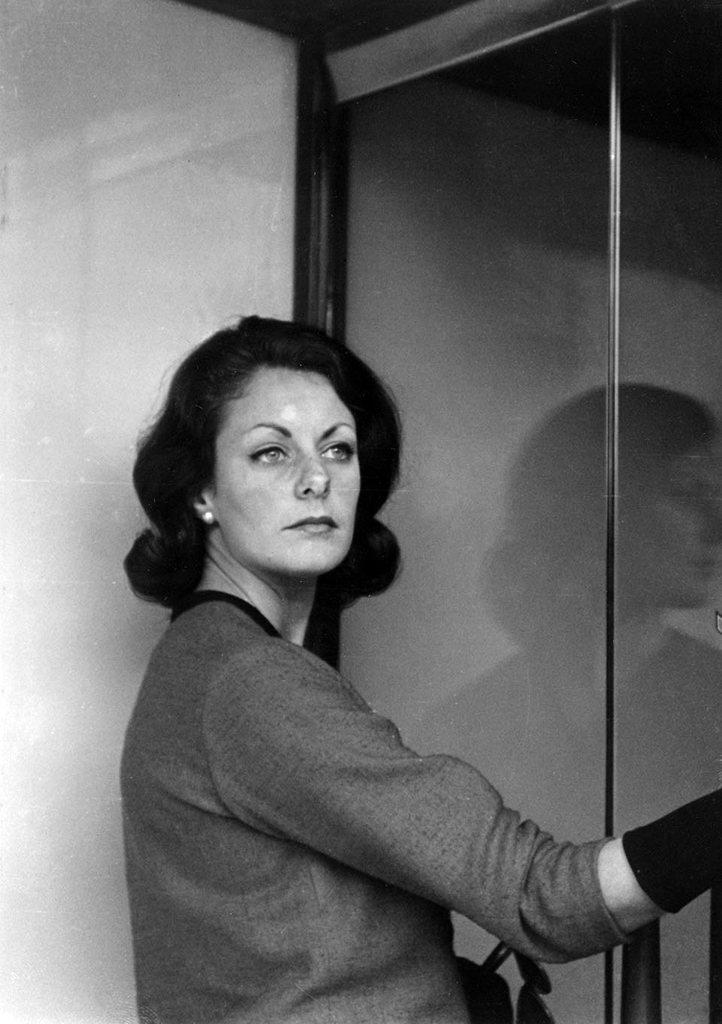What is the main subject of the image? There is a person standing in the center of the image. What can be seen in the background of the image? There is a wall and a lift in the background of the image. How many spiders are crawling on the person's mouth in the image? There are no spiders present in the image, and the person's mouth is not visible. 